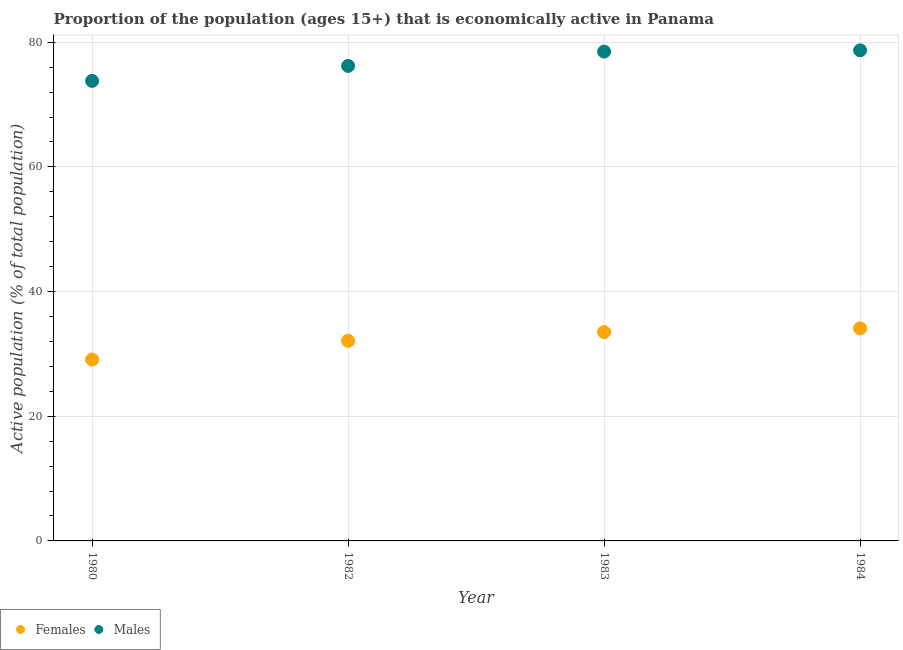What is the percentage of economically active female population in 1980?
Keep it short and to the point. 29.1. Across all years, what is the maximum percentage of economically active female population?
Give a very brief answer. 34.1. Across all years, what is the minimum percentage of economically active male population?
Give a very brief answer. 73.8. In which year was the percentage of economically active male population maximum?
Your answer should be compact. 1984. In which year was the percentage of economically active male population minimum?
Your answer should be very brief. 1980. What is the total percentage of economically active male population in the graph?
Make the answer very short. 307.2. What is the difference between the percentage of economically active female population in 1982 and the percentage of economically active male population in 1984?
Your answer should be very brief. -46.6. What is the average percentage of economically active female population per year?
Provide a short and direct response. 32.2. In the year 1980, what is the difference between the percentage of economically active male population and percentage of economically active female population?
Your answer should be very brief. 44.7. What is the ratio of the percentage of economically active male population in 1983 to that in 1984?
Your answer should be very brief. 1. Is the difference between the percentage of economically active male population in 1983 and 1984 greater than the difference between the percentage of economically active female population in 1983 and 1984?
Offer a very short reply. Yes. What is the difference between the highest and the second highest percentage of economically active male population?
Provide a succinct answer. 0.2. What is the difference between the highest and the lowest percentage of economically active female population?
Provide a short and direct response. 5. In how many years, is the percentage of economically active male population greater than the average percentage of economically active male population taken over all years?
Provide a succinct answer. 2. Is the sum of the percentage of economically active female population in 1980 and 1983 greater than the maximum percentage of economically active male population across all years?
Your answer should be compact. No. Is the percentage of economically active female population strictly greater than the percentage of economically active male population over the years?
Offer a very short reply. No. Is the percentage of economically active male population strictly less than the percentage of economically active female population over the years?
Keep it short and to the point. No. How many dotlines are there?
Your response must be concise. 2. What is the difference between two consecutive major ticks on the Y-axis?
Your answer should be compact. 20. Are the values on the major ticks of Y-axis written in scientific E-notation?
Offer a very short reply. No. Where does the legend appear in the graph?
Keep it short and to the point. Bottom left. How many legend labels are there?
Make the answer very short. 2. What is the title of the graph?
Provide a short and direct response. Proportion of the population (ages 15+) that is economically active in Panama. What is the label or title of the Y-axis?
Offer a terse response. Active population (% of total population). What is the Active population (% of total population) of Females in 1980?
Provide a succinct answer. 29.1. What is the Active population (% of total population) in Males in 1980?
Offer a very short reply. 73.8. What is the Active population (% of total population) of Females in 1982?
Ensure brevity in your answer.  32.1. What is the Active population (% of total population) in Males in 1982?
Offer a terse response. 76.2. What is the Active population (% of total population) of Females in 1983?
Your answer should be compact. 33.5. What is the Active population (% of total population) of Males in 1983?
Ensure brevity in your answer.  78.5. What is the Active population (% of total population) in Females in 1984?
Your answer should be compact. 34.1. What is the Active population (% of total population) of Males in 1984?
Keep it short and to the point. 78.7. Across all years, what is the maximum Active population (% of total population) of Females?
Your response must be concise. 34.1. Across all years, what is the maximum Active population (% of total population) of Males?
Provide a succinct answer. 78.7. Across all years, what is the minimum Active population (% of total population) of Females?
Your response must be concise. 29.1. Across all years, what is the minimum Active population (% of total population) in Males?
Offer a very short reply. 73.8. What is the total Active population (% of total population) of Females in the graph?
Offer a very short reply. 128.8. What is the total Active population (% of total population) in Males in the graph?
Offer a terse response. 307.2. What is the difference between the Active population (% of total population) in Males in 1980 and that in 1982?
Give a very brief answer. -2.4. What is the difference between the Active population (% of total population) in Females in 1982 and that in 1984?
Keep it short and to the point. -2. What is the difference between the Active population (% of total population) of Males in 1982 and that in 1984?
Your answer should be very brief. -2.5. What is the difference between the Active population (% of total population) of Females in 1980 and the Active population (% of total population) of Males in 1982?
Keep it short and to the point. -47.1. What is the difference between the Active population (% of total population) of Females in 1980 and the Active population (% of total population) of Males in 1983?
Keep it short and to the point. -49.4. What is the difference between the Active population (% of total population) in Females in 1980 and the Active population (% of total population) in Males in 1984?
Your response must be concise. -49.6. What is the difference between the Active population (% of total population) of Females in 1982 and the Active population (% of total population) of Males in 1983?
Offer a terse response. -46.4. What is the difference between the Active population (% of total population) in Females in 1982 and the Active population (% of total population) in Males in 1984?
Your answer should be compact. -46.6. What is the difference between the Active population (% of total population) in Females in 1983 and the Active population (% of total population) in Males in 1984?
Provide a succinct answer. -45.2. What is the average Active population (% of total population) of Females per year?
Offer a very short reply. 32.2. What is the average Active population (% of total population) of Males per year?
Offer a terse response. 76.8. In the year 1980, what is the difference between the Active population (% of total population) of Females and Active population (% of total population) of Males?
Your answer should be compact. -44.7. In the year 1982, what is the difference between the Active population (% of total population) of Females and Active population (% of total population) of Males?
Provide a succinct answer. -44.1. In the year 1983, what is the difference between the Active population (% of total population) of Females and Active population (% of total population) of Males?
Offer a terse response. -45. In the year 1984, what is the difference between the Active population (% of total population) in Females and Active population (% of total population) in Males?
Ensure brevity in your answer.  -44.6. What is the ratio of the Active population (% of total population) of Females in 1980 to that in 1982?
Give a very brief answer. 0.91. What is the ratio of the Active population (% of total population) in Males in 1980 to that in 1982?
Provide a short and direct response. 0.97. What is the ratio of the Active population (% of total population) of Females in 1980 to that in 1983?
Offer a very short reply. 0.87. What is the ratio of the Active population (% of total population) of Males in 1980 to that in 1983?
Ensure brevity in your answer.  0.94. What is the ratio of the Active population (% of total population) of Females in 1980 to that in 1984?
Offer a terse response. 0.85. What is the ratio of the Active population (% of total population) in Males in 1980 to that in 1984?
Provide a short and direct response. 0.94. What is the ratio of the Active population (% of total population) in Females in 1982 to that in 1983?
Provide a short and direct response. 0.96. What is the ratio of the Active population (% of total population) of Males in 1982 to that in 1983?
Ensure brevity in your answer.  0.97. What is the ratio of the Active population (% of total population) of Females in 1982 to that in 1984?
Give a very brief answer. 0.94. What is the ratio of the Active population (% of total population) in Males in 1982 to that in 1984?
Make the answer very short. 0.97. What is the ratio of the Active population (% of total population) in Females in 1983 to that in 1984?
Offer a very short reply. 0.98. What is the ratio of the Active population (% of total population) of Males in 1983 to that in 1984?
Give a very brief answer. 1. What is the difference between the highest and the second highest Active population (% of total population) of Females?
Make the answer very short. 0.6. What is the difference between the highest and the lowest Active population (% of total population) of Females?
Offer a terse response. 5. 